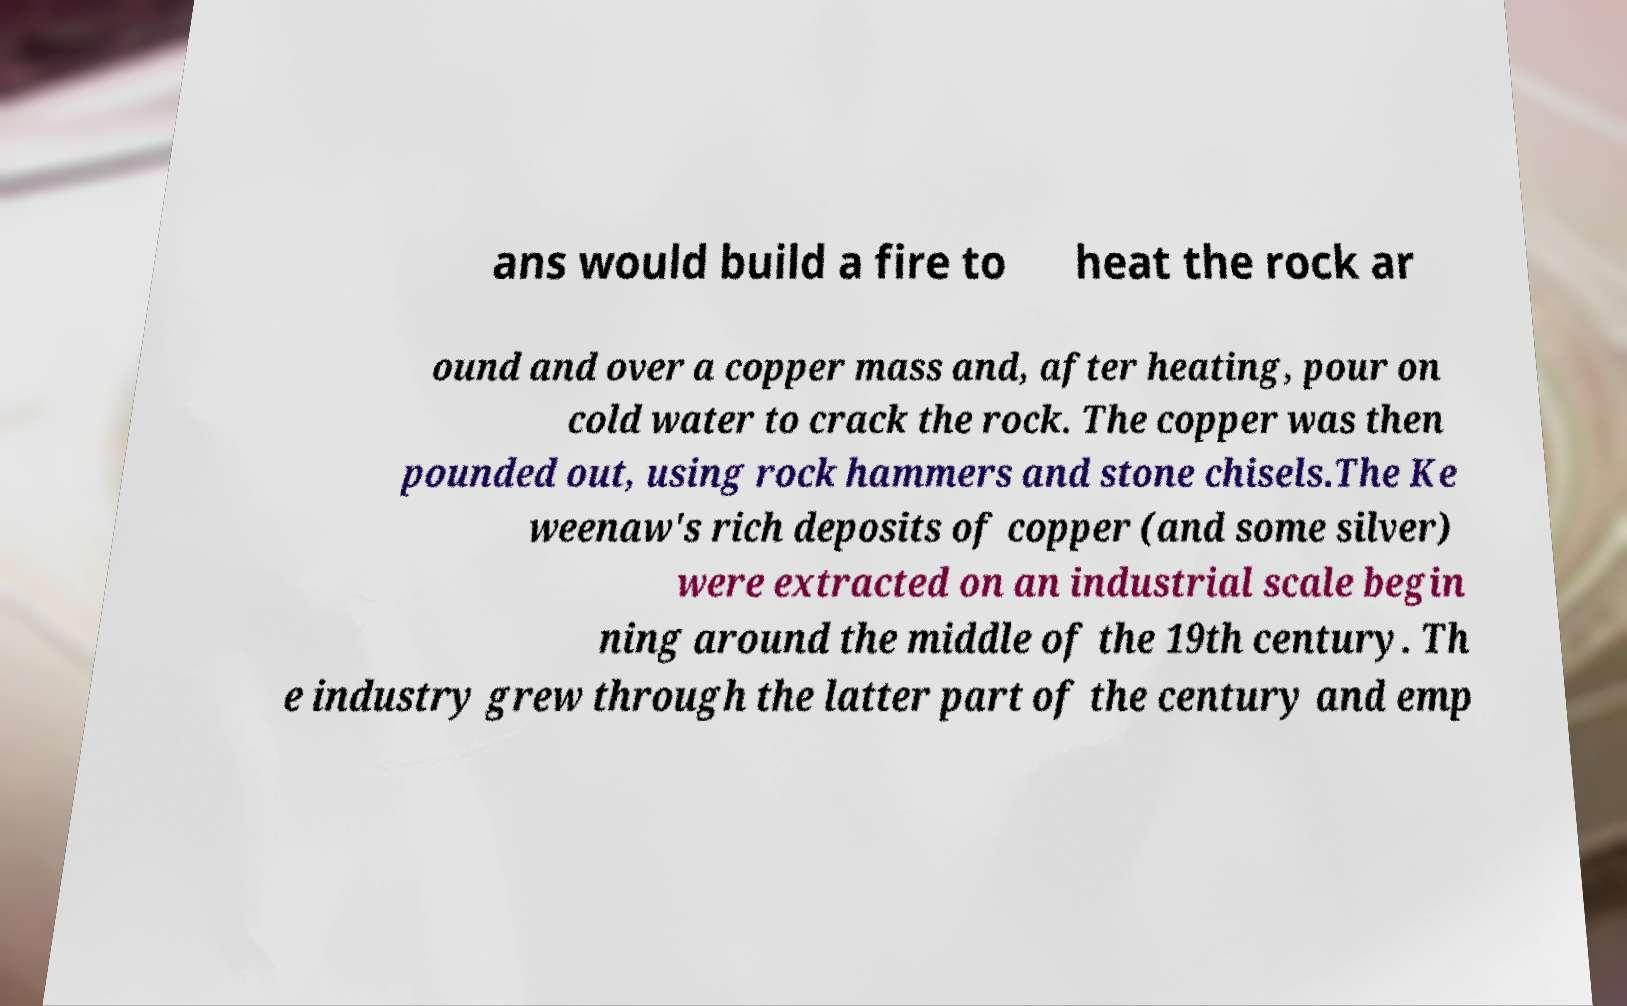For documentation purposes, I need the text within this image transcribed. Could you provide that? ans would build a fire to heat the rock ar ound and over a copper mass and, after heating, pour on cold water to crack the rock. The copper was then pounded out, using rock hammers and stone chisels.The Ke weenaw's rich deposits of copper (and some silver) were extracted on an industrial scale begin ning around the middle of the 19th century. Th e industry grew through the latter part of the century and emp 